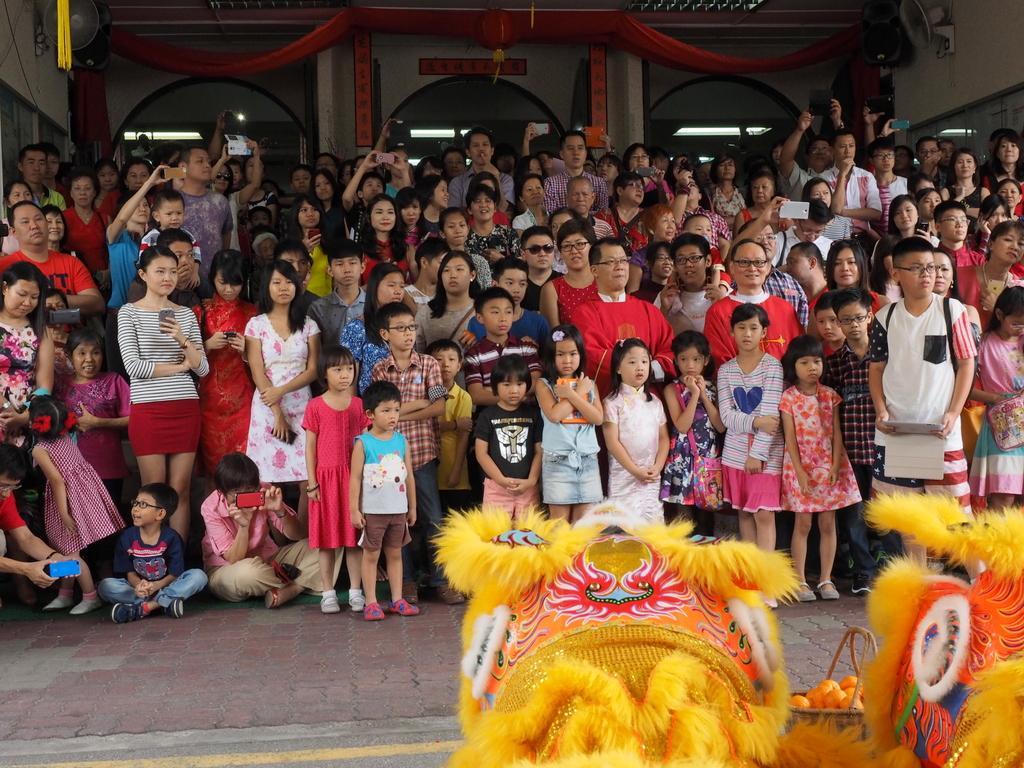How would you summarize this image in a sentence or two? In this picture we can see a group of people standing and two people sitting. Some people holding the objects. In front of the people there are fruits in the basket and some yellow objects. Behind the people there are some decorative items and it looks like a building. 